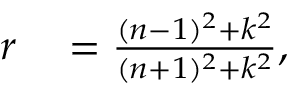Convert formula to latex. <formula><loc_0><loc_0><loc_500><loc_500>\begin{array} { r l } { r } & = \frac { ( n - 1 ) ^ { 2 } + k ^ { 2 } } { ( n + 1 ) ^ { 2 } + k ^ { 2 } } , } \end{array}</formula> 